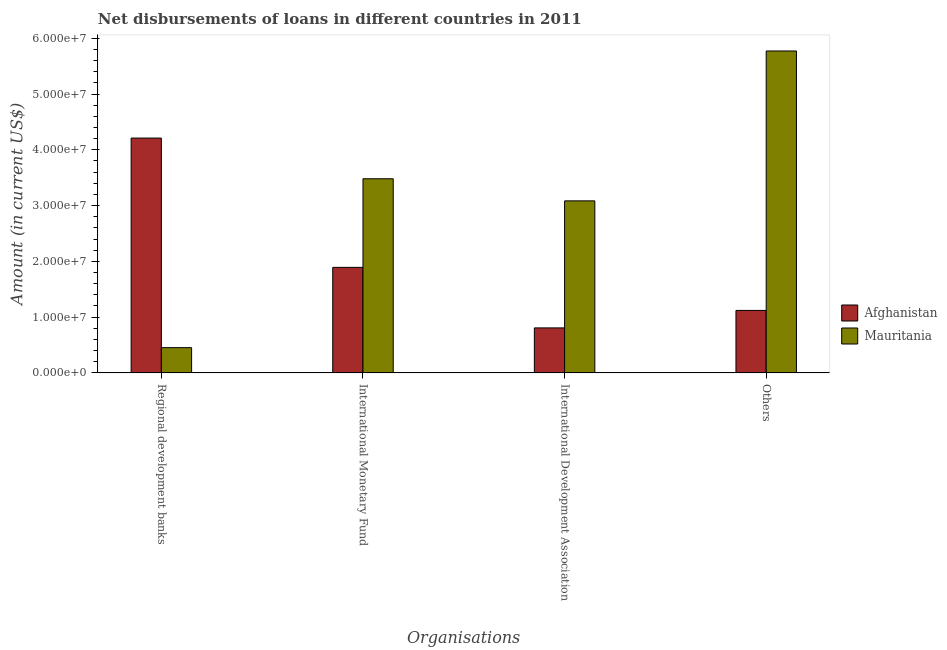Are the number of bars on each tick of the X-axis equal?
Offer a very short reply. Yes. How many bars are there on the 3rd tick from the right?
Provide a succinct answer. 2. What is the label of the 1st group of bars from the left?
Your response must be concise. Regional development banks. What is the amount of loan disimbursed by other organisations in Mauritania?
Ensure brevity in your answer.  5.77e+07. Across all countries, what is the maximum amount of loan disimbursed by international monetary fund?
Your response must be concise. 3.48e+07. Across all countries, what is the minimum amount of loan disimbursed by international development association?
Offer a very short reply. 8.06e+06. In which country was the amount of loan disimbursed by international development association maximum?
Provide a succinct answer. Mauritania. In which country was the amount of loan disimbursed by international monetary fund minimum?
Give a very brief answer. Afghanistan. What is the total amount of loan disimbursed by international monetary fund in the graph?
Provide a short and direct response. 5.37e+07. What is the difference between the amount of loan disimbursed by international development association in Mauritania and that in Afghanistan?
Keep it short and to the point. 2.28e+07. What is the difference between the amount of loan disimbursed by regional development banks in Afghanistan and the amount of loan disimbursed by international monetary fund in Mauritania?
Give a very brief answer. 7.30e+06. What is the average amount of loan disimbursed by other organisations per country?
Your answer should be very brief. 3.45e+07. What is the difference between the amount of loan disimbursed by international development association and amount of loan disimbursed by other organisations in Mauritania?
Ensure brevity in your answer.  -2.69e+07. What is the ratio of the amount of loan disimbursed by international development association in Afghanistan to that in Mauritania?
Provide a short and direct response. 0.26. Is the amount of loan disimbursed by regional development banks in Mauritania less than that in Afghanistan?
Keep it short and to the point. Yes. What is the difference between the highest and the second highest amount of loan disimbursed by international development association?
Offer a terse response. 2.28e+07. What is the difference between the highest and the lowest amount of loan disimbursed by international monetary fund?
Provide a short and direct response. 1.59e+07. What does the 1st bar from the left in Regional development banks represents?
Offer a terse response. Afghanistan. What does the 2nd bar from the right in International Monetary Fund represents?
Provide a short and direct response. Afghanistan. Is it the case that in every country, the sum of the amount of loan disimbursed by regional development banks and amount of loan disimbursed by international monetary fund is greater than the amount of loan disimbursed by international development association?
Provide a short and direct response. Yes. How many bars are there?
Ensure brevity in your answer.  8. How many countries are there in the graph?
Offer a terse response. 2. What is the difference between two consecutive major ticks on the Y-axis?
Keep it short and to the point. 1.00e+07. Where does the legend appear in the graph?
Provide a short and direct response. Center right. What is the title of the graph?
Offer a terse response. Net disbursements of loans in different countries in 2011. Does "Montenegro" appear as one of the legend labels in the graph?
Your answer should be compact. No. What is the label or title of the X-axis?
Offer a very short reply. Organisations. What is the label or title of the Y-axis?
Provide a succinct answer. Amount (in current US$). What is the Amount (in current US$) of Afghanistan in Regional development banks?
Provide a short and direct response. 4.21e+07. What is the Amount (in current US$) in Mauritania in Regional development banks?
Offer a very short reply. 4.52e+06. What is the Amount (in current US$) of Afghanistan in International Monetary Fund?
Ensure brevity in your answer.  1.89e+07. What is the Amount (in current US$) of Mauritania in International Monetary Fund?
Provide a short and direct response. 3.48e+07. What is the Amount (in current US$) in Afghanistan in International Development Association?
Your response must be concise. 8.06e+06. What is the Amount (in current US$) in Mauritania in International Development Association?
Offer a very short reply. 3.08e+07. What is the Amount (in current US$) of Afghanistan in Others?
Offer a terse response. 1.12e+07. What is the Amount (in current US$) of Mauritania in Others?
Your response must be concise. 5.77e+07. Across all Organisations, what is the maximum Amount (in current US$) of Afghanistan?
Ensure brevity in your answer.  4.21e+07. Across all Organisations, what is the maximum Amount (in current US$) of Mauritania?
Offer a very short reply. 5.77e+07. Across all Organisations, what is the minimum Amount (in current US$) in Afghanistan?
Offer a very short reply. 8.06e+06. Across all Organisations, what is the minimum Amount (in current US$) in Mauritania?
Make the answer very short. 4.52e+06. What is the total Amount (in current US$) of Afghanistan in the graph?
Your answer should be compact. 8.03e+07. What is the total Amount (in current US$) of Mauritania in the graph?
Your response must be concise. 1.28e+08. What is the difference between the Amount (in current US$) in Afghanistan in Regional development banks and that in International Monetary Fund?
Ensure brevity in your answer.  2.32e+07. What is the difference between the Amount (in current US$) in Mauritania in Regional development banks and that in International Monetary Fund?
Keep it short and to the point. -3.03e+07. What is the difference between the Amount (in current US$) in Afghanistan in Regional development banks and that in International Development Association?
Your answer should be very brief. 3.40e+07. What is the difference between the Amount (in current US$) of Mauritania in Regional development banks and that in International Development Association?
Your response must be concise. -2.63e+07. What is the difference between the Amount (in current US$) in Afghanistan in Regional development banks and that in Others?
Provide a succinct answer. 3.09e+07. What is the difference between the Amount (in current US$) of Mauritania in Regional development banks and that in Others?
Provide a succinct answer. -5.32e+07. What is the difference between the Amount (in current US$) in Afghanistan in International Monetary Fund and that in International Development Association?
Offer a terse response. 1.09e+07. What is the difference between the Amount (in current US$) in Mauritania in International Monetary Fund and that in International Development Association?
Give a very brief answer. 3.96e+06. What is the difference between the Amount (in current US$) of Afghanistan in International Monetary Fund and that in Others?
Provide a short and direct response. 7.72e+06. What is the difference between the Amount (in current US$) of Mauritania in International Monetary Fund and that in Others?
Offer a very short reply. -2.29e+07. What is the difference between the Amount (in current US$) in Afghanistan in International Development Association and that in Others?
Your response must be concise. -3.14e+06. What is the difference between the Amount (in current US$) of Mauritania in International Development Association and that in Others?
Provide a short and direct response. -2.69e+07. What is the difference between the Amount (in current US$) in Afghanistan in Regional development banks and the Amount (in current US$) in Mauritania in International Monetary Fund?
Provide a short and direct response. 7.30e+06. What is the difference between the Amount (in current US$) of Afghanistan in Regional development banks and the Amount (in current US$) of Mauritania in International Development Association?
Provide a succinct answer. 1.13e+07. What is the difference between the Amount (in current US$) in Afghanistan in Regional development banks and the Amount (in current US$) in Mauritania in Others?
Your response must be concise. -1.56e+07. What is the difference between the Amount (in current US$) of Afghanistan in International Monetary Fund and the Amount (in current US$) of Mauritania in International Development Association?
Offer a terse response. -1.19e+07. What is the difference between the Amount (in current US$) in Afghanistan in International Monetary Fund and the Amount (in current US$) in Mauritania in Others?
Offer a very short reply. -3.88e+07. What is the difference between the Amount (in current US$) of Afghanistan in International Development Association and the Amount (in current US$) of Mauritania in Others?
Make the answer very short. -4.97e+07. What is the average Amount (in current US$) in Afghanistan per Organisations?
Provide a succinct answer. 2.01e+07. What is the average Amount (in current US$) in Mauritania per Organisations?
Your response must be concise. 3.20e+07. What is the difference between the Amount (in current US$) in Afghanistan and Amount (in current US$) in Mauritania in Regional development banks?
Your answer should be compact. 3.76e+07. What is the difference between the Amount (in current US$) of Afghanistan and Amount (in current US$) of Mauritania in International Monetary Fund?
Offer a terse response. -1.59e+07. What is the difference between the Amount (in current US$) in Afghanistan and Amount (in current US$) in Mauritania in International Development Association?
Give a very brief answer. -2.28e+07. What is the difference between the Amount (in current US$) in Afghanistan and Amount (in current US$) in Mauritania in Others?
Your answer should be very brief. -4.65e+07. What is the ratio of the Amount (in current US$) of Afghanistan in Regional development banks to that in International Monetary Fund?
Your response must be concise. 2.23. What is the ratio of the Amount (in current US$) in Mauritania in Regional development banks to that in International Monetary Fund?
Offer a terse response. 0.13. What is the ratio of the Amount (in current US$) of Afghanistan in Regional development banks to that in International Development Association?
Give a very brief answer. 5.22. What is the ratio of the Amount (in current US$) in Mauritania in Regional development banks to that in International Development Association?
Provide a short and direct response. 0.15. What is the ratio of the Amount (in current US$) in Afghanistan in Regional development banks to that in Others?
Your answer should be compact. 3.76. What is the ratio of the Amount (in current US$) of Mauritania in Regional development banks to that in Others?
Your answer should be very brief. 0.08. What is the ratio of the Amount (in current US$) in Afghanistan in International Monetary Fund to that in International Development Association?
Make the answer very short. 2.35. What is the ratio of the Amount (in current US$) in Mauritania in International Monetary Fund to that in International Development Association?
Ensure brevity in your answer.  1.13. What is the ratio of the Amount (in current US$) of Afghanistan in International Monetary Fund to that in Others?
Your answer should be compact. 1.69. What is the ratio of the Amount (in current US$) of Mauritania in International Monetary Fund to that in Others?
Offer a very short reply. 0.6. What is the ratio of the Amount (in current US$) in Afghanistan in International Development Association to that in Others?
Your answer should be compact. 0.72. What is the ratio of the Amount (in current US$) in Mauritania in International Development Association to that in Others?
Ensure brevity in your answer.  0.53. What is the difference between the highest and the second highest Amount (in current US$) in Afghanistan?
Your response must be concise. 2.32e+07. What is the difference between the highest and the second highest Amount (in current US$) in Mauritania?
Your answer should be very brief. 2.29e+07. What is the difference between the highest and the lowest Amount (in current US$) in Afghanistan?
Your answer should be compact. 3.40e+07. What is the difference between the highest and the lowest Amount (in current US$) of Mauritania?
Ensure brevity in your answer.  5.32e+07. 